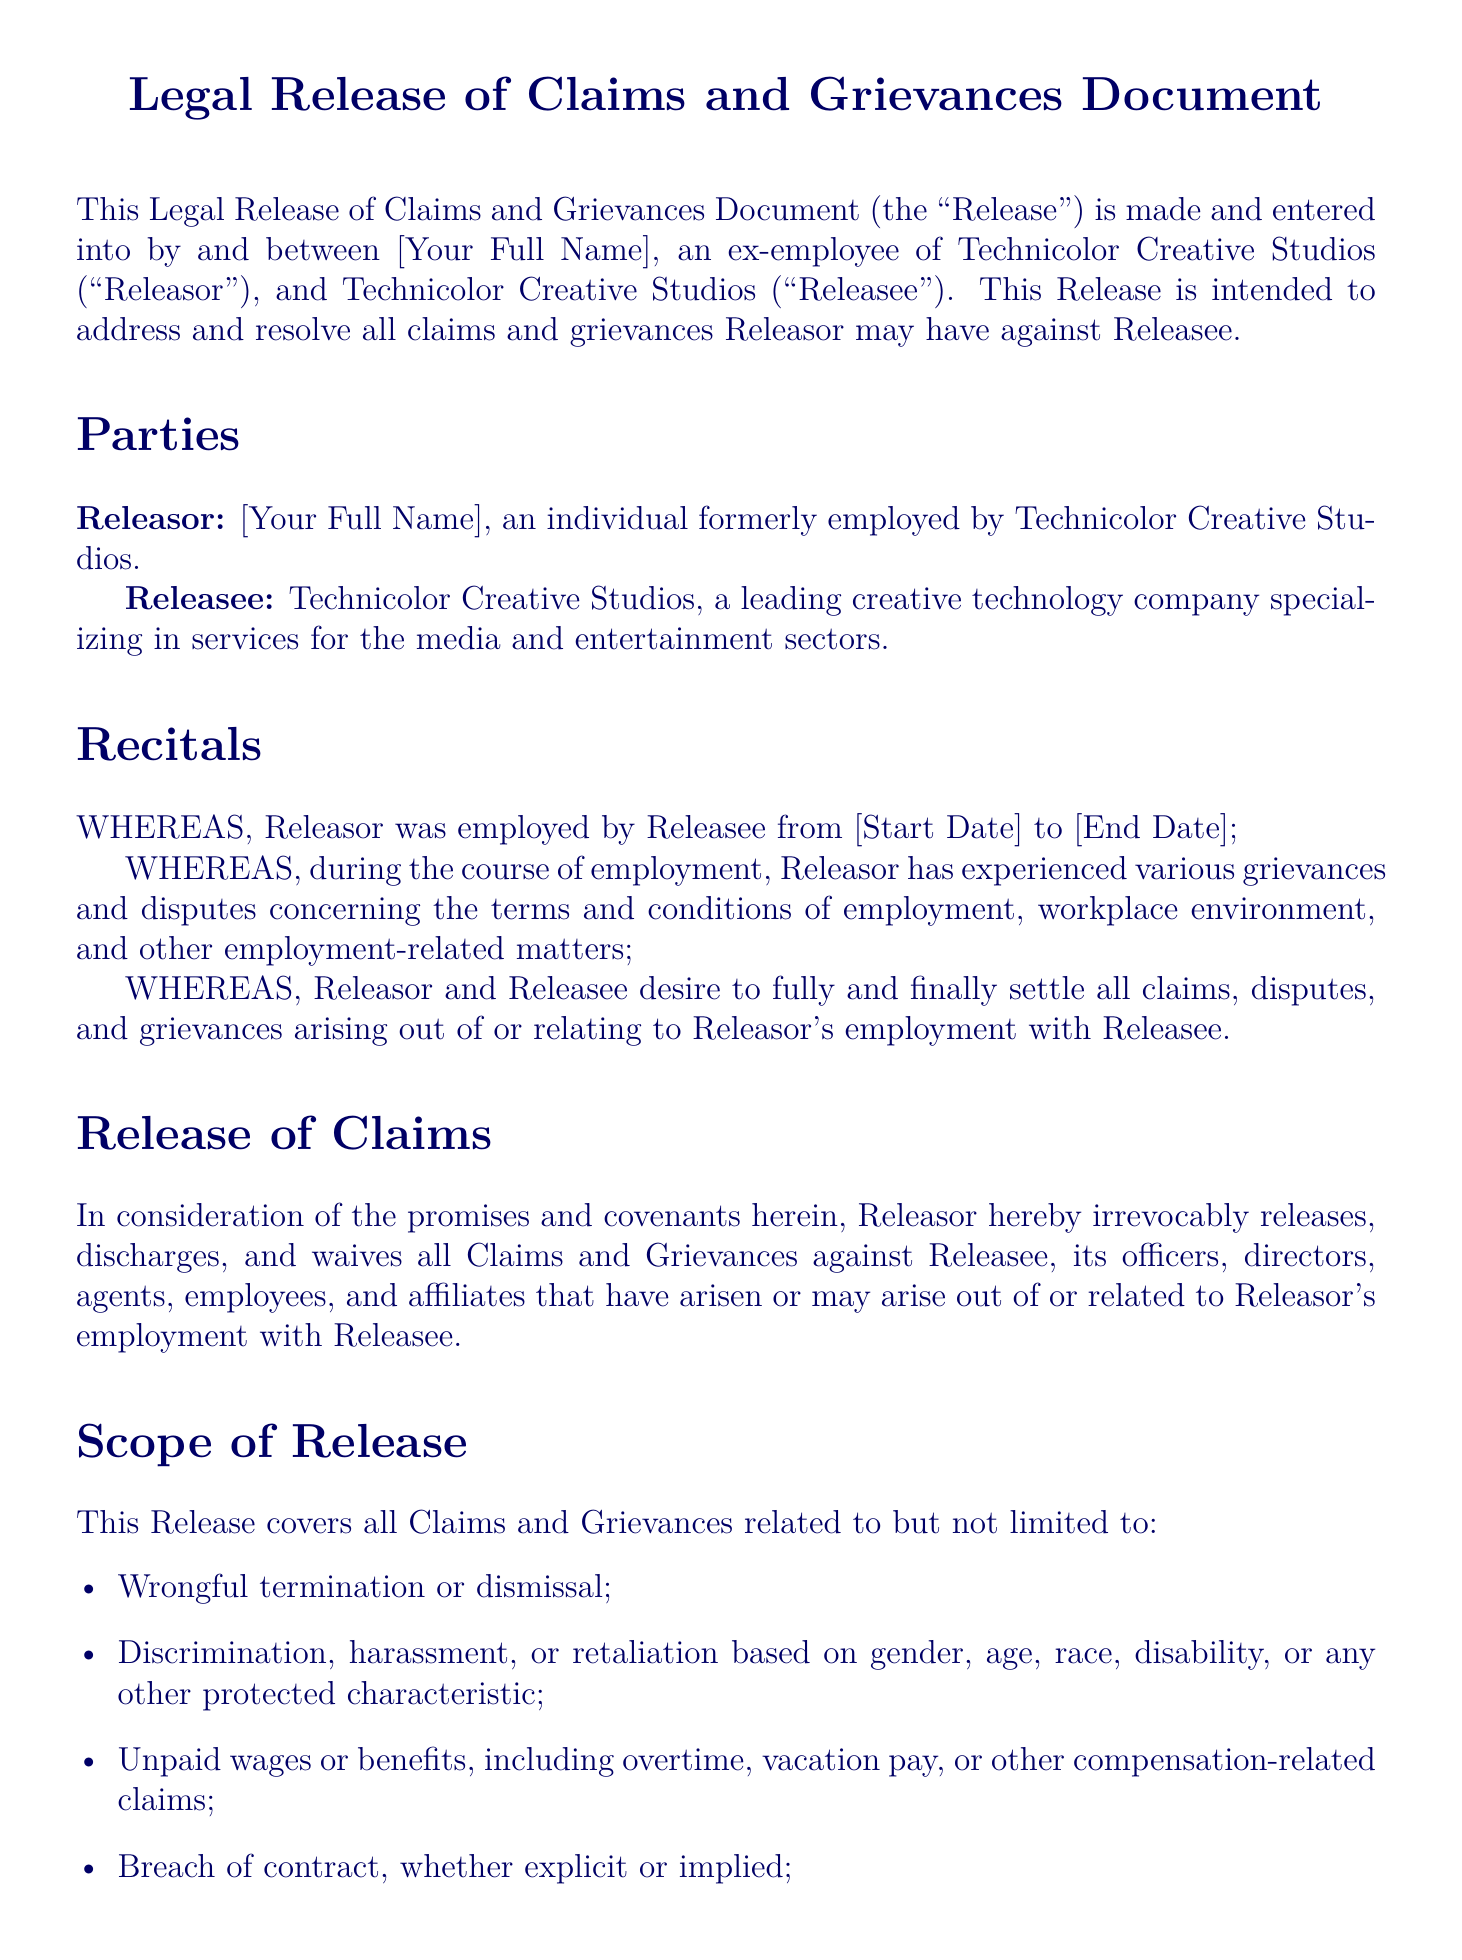What is the title of the document? The title of the document is stated in the center of the first page, indicating the purpose of the document.
Answer: Legal Release of Claims and Grievances Document Who is the Releasor? The Releasor is identified as an individual who has previously been employed by Technicolor Creative Studios.
Answer: [Your Full Name] What time period did the Releasor work for Technicolor Creative Studios? The period of employment is mentioned within the recitals section of the document.
Answer: [Start Date] to [End Date] Which type of grievances does the Release cover? The specific types of grievances are listed under the scope of release section.
Answer: Wrongful termination or dismissal, discrimination, harassment, unpaid wages, breach of contract, mental or emotional distress What does this Release signify in terms of liability? The document clearly states the nature of this Release in relation to acceptance of wrongdoing or fault.
Answer: No Admission of Liability How is the Release executed? The execution of the Release is indicated by the signature section, where the parties must sign and date the document.
Answer: Signatures What must the Releasor provide to complete the document? The document asks for information from the Releasor to finalize the agreement.
Answer: [Your Full Name] and Date What is the purpose of this document? The overall purpose is summarized in the introductory sentences of the document, outlining the intention between the parties.
Answer: To address and resolve all claims and grievances What is included in the scope of release? The scope of release incorporates specific legal claims and categories.
Answer: Claims related to wrongful termination, discrimination, unpaid wages, breach of contract, and emotional distress 